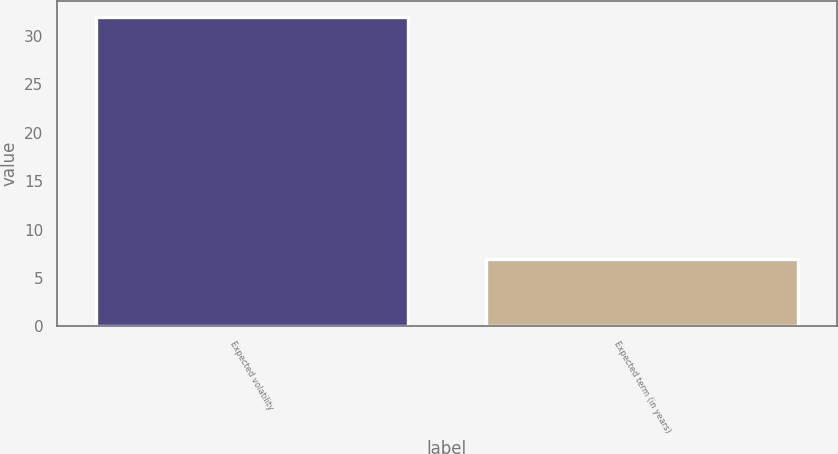Convert chart. <chart><loc_0><loc_0><loc_500><loc_500><bar_chart><fcel>Expected volatility<fcel>Expected term (in years)<nl><fcel>32<fcel>7<nl></chart> 